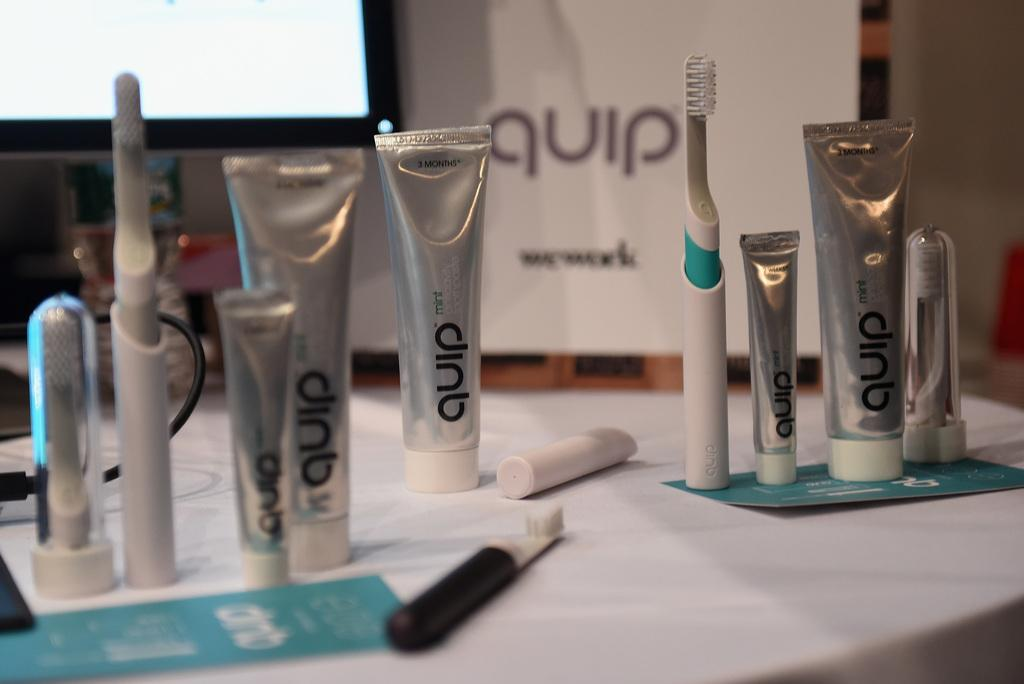What items are on the table in the image? There are toothpastes on a table in the image. What color is the table? The table is white. What can be seen in the background of the image? There is a screen in the background of the image. What rhythm is the toothpaste playing in the image? There is no rhythm or music present in the image; it is a still image of toothpastes on a table. 